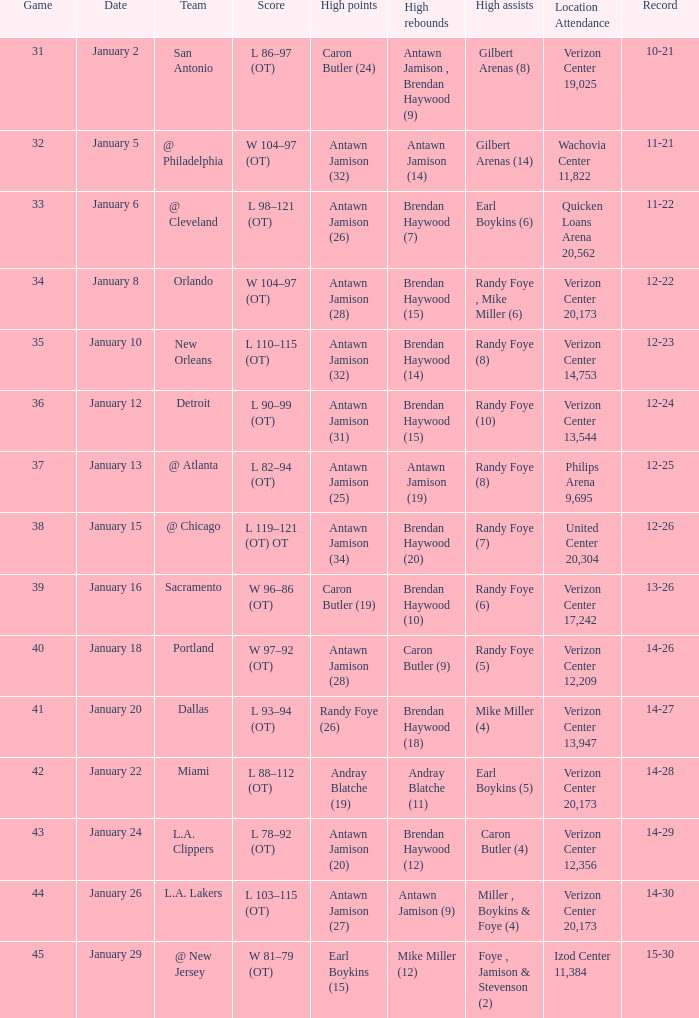What day was the record 14-27? January 20. 